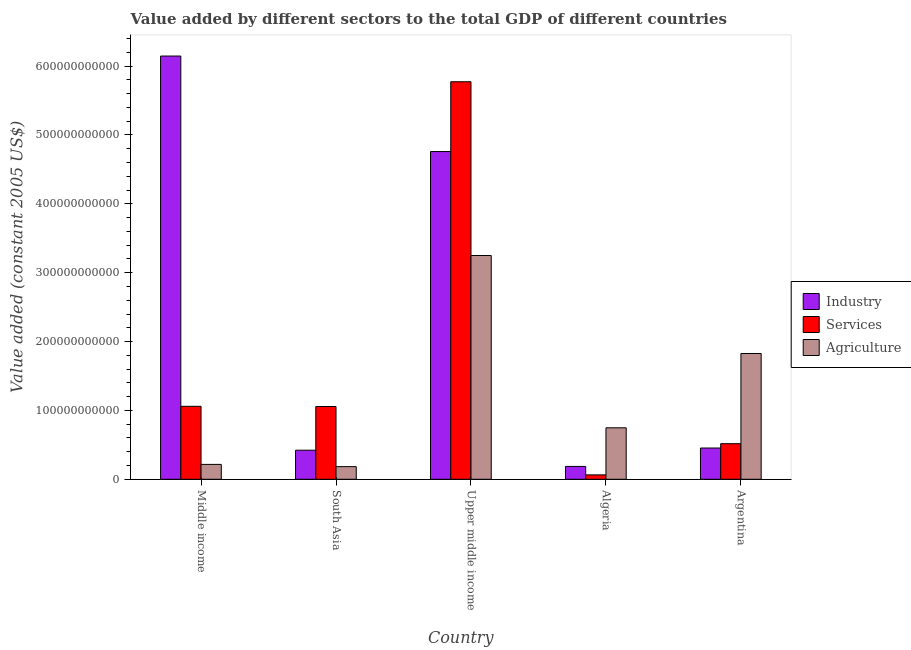How many different coloured bars are there?
Make the answer very short. 3. How many groups of bars are there?
Your answer should be very brief. 5. Are the number of bars on each tick of the X-axis equal?
Provide a short and direct response. Yes. How many bars are there on the 1st tick from the right?
Keep it short and to the point. 3. What is the value added by industrial sector in Argentina?
Your response must be concise. 4.54e+1. Across all countries, what is the maximum value added by services?
Give a very brief answer. 5.77e+11. Across all countries, what is the minimum value added by agricultural sector?
Provide a short and direct response. 1.84e+1. In which country was the value added by agricultural sector maximum?
Make the answer very short. Upper middle income. In which country was the value added by services minimum?
Give a very brief answer. Algeria. What is the total value added by agricultural sector in the graph?
Provide a succinct answer. 6.22e+11. What is the difference between the value added by services in Middle income and that in Upper middle income?
Your answer should be compact. -4.71e+11. What is the difference between the value added by industrial sector in Argentina and the value added by agricultural sector in Upper middle income?
Your answer should be compact. -2.80e+11. What is the average value added by services per country?
Your response must be concise. 1.69e+11. What is the difference between the value added by industrial sector and value added by agricultural sector in Middle income?
Your answer should be very brief. 5.93e+11. In how many countries, is the value added by industrial sector greater than 140000000000 US$?
Make the answer very short. 2. What is the ratio of the value added by agricultural sector in Argentina to that in Upper middle income?
Offer a terse response. 0.56. Is the value added by industrial sector in Algeria less than that in South Asia?
Provide a succinct answer. Yes. Is the difference between the value added by services in Algeria and Argentina greater than the difference between the value added by industrial sector in Algeria and Argentina?
Provide a succinct answer. No. What is the difference between the highest and the second highest value added by services?
Offer a terse response. 4.71e+11. What is the difference between the highest and the lowest value added by agricultural sector?
Offer a terse response. 3.07e+11. Is the sum of the value added by industrial sector in Algeria and South Asia greater than the maximum value added by agricultural sector across all countries?
Your answer should be very brief. No. What does the 2nd bar from the left in Middle income represents?
Your response must be concise. Services. What does the 2nd bar from the right in Upper middle income represents?
Your response must be concise. Services. How many bars are there?
Make the answer very short. 15. How many countries are there in the graph?
Make the answer very short. 5. What is the difference between two consecutive major ticks on the Y-axis?
Provide a succinct answer. 1.00e+11. Are the values on the major ticks of Y-axis written in scientific E-notation?
Provide a succinct answer. No. Where does the legend appear in the graph?
Offer a very short reply. Center right. How many legend labels are there?
Offer a very short reply. 3. What is the title of the graph?
Ensure brevity in your answer.  Value added by different sectors to the total GDP of different countries. What is the label or title of the Y-axis?
Offer a terse response. Value added (constant 2005 US$). What is the Value added (constant 2005 US$) in Industry in Middle income?
Make the answer very short. 6.15e+11. What is the Value added (constant 2005 US$) in Services in Middle income?
Your answer should be compact. 1.06e+11. What is the Value added (constant 2005 US$) in Agriculture in Middle income?
Your answer should be compact. 2.16e+1. What is the Value added (constant 2005 US$) of Industry in South Asia?
Keep it short and to the point. 4.22e+1. What is the Value added (constant 2005 US$) of Services in South Asia?
Offer a terse response. 1.06e+11. What is the Value added (constant 2005 US$) of Agriculture in South Asia?
Provide a short and direct response. 1.84e+1. What is the Value added (constant 2005 US$) in Industry in Upper middle income?
Your response must be concise. 4.76e+11. What is the Value added (constant 2005 US$) of Services in Upper middle income?
Keep it short and to the point. 5.77e+11. What is the Value added (constant 2005 US$) in Agriculture in Upper middle income?
Your answer should be compact. 3.25e+11. What is the Value added (constant 2005 US$) in Industry in Algeria?
Offer a very short reply. 1.86e+1. What is the Value added (constant 2005 US$) in Services in Algeria?
Your answer should be very brief. 6.38e+09. What is the Value added (constant 2005 US$) in Agriculture in Algeria?
Make the answer very short. 7.47e+1. What is the Value added (constant 2005 US$) of Industry in Argentina?
Make the answer very short. 4.54e+1. What is the Value added (constant 2005 US$) of Services in Argentina?
Keep it short and to the point. 5.17e+1. What is the Value added (constant 2005 US$) of Agriculture in Argentina?
Provide a short and direct response. 1.83e+11. Across all countries, what is the maximum Value added (constant 2005 US$) in Industry?
Keep it short and to the point. 6.15e+11. Across all countries, what is the maximum Value added (constant 2005 US$) in Services?
Your answer should be compact. 5.77e+11. Across all countries, what is the maximum Value added (constant 2005 US$) of Agriculture?
Offer a terse response. 3.25e+11. Across all countries, what is the minimum Value added (constant 2005 US$) in Industry?
Your response must be concise. 1.86e+1. Across all countries, what is the minimum Value added (constant 2005 US$) of Services?
Your answer should be very brief. 6.38e+09. Across all countries, what is the minimum Value added (constant 2005 US$) of Agriculture?
Provide a short and direct response. 1.84e+1. What is the total Value added (constant 2005 US$) in Industry in the graph?
Offer a very short reply. 1.20e+12. What is the total Value added (constant 2005 US$) of Services in the graph?
Provide a short and direct response. 8.47e+11. What is the total Value added (constant 2005 US$) of Agriculture in the graph?
Your answer should be very brief. 6.22e+11. What is the difference between the Value added (constant 2005 US$) of Industry in Middle income and that in South Asia?
Ensure brevity in your answer.  5.72e+11. What is the difference between the Value added (constant 2005 US$) in Services in Middle income and that in South Asia?
Ensure brevity in your answer.  3.20e+08. What is the difference between the Value added (constant 2005 US$) in Agriculture in Middle income and that in South Asia?
Keep it short and to the point. 3.24e+09. What is the difference between the Value added (constant 2005 US$) in Industry in Middle income and that in Upper middle income?
Provide a short and direct response. 1.39e+11. What is the difference between the Value added (constant 2005 US$) in Services in Middle income and that in Upper middle income?
Your response must be concise. -4.71e+11. What is the difference between the Value added (constant 2005 US$) of Agriculture in Middle income and that in Upper middle income?
Ensure brevity in your answer.  -3.03e+11. What is the difference between the Value added (constant 2005 US$) of Industry in Middle income and that in Algeria?
Offer a terse response. 5.96e+11. What is the difference between the Value added (constant 2005 US$) in Services in Middle income and that in Algeria?
Give a very brief answer. 9.96e+1. What is the difference between the Value added (constant 2005 US$) of Agriculture in Middle income and that in Algeria?
Give a very brief answer. -5.31e+1. What is the difference between the Value added (constant 2005 US$) in Industry in Middle income and that in Argentina?
Your answer should be compact. 5.69e+11. What is the difference between the Value added (constant 2005 US$) of Services in Middle income and that in Argentina?
Provide a short and direct response. 5.43e+1. What is the difference between the Value added (constant 2005 US$) in Agriculture in Middle income and that in Argentina?
Your answer should be very brief. -1.61e+11. What is the difference between the Value added (constant 2005 US$) in Industry in South Asia and that in Upper middle income?
Ensure brevity in your answer.  -4.34e+11. What is the difference between the Value added (constant 2005 US$) of Services in South Asia and that in Upper middle income?
Your answer should be compact. -4.72e+11. What is the difference between the Value added (constant 2005 US$) in Agriculture in South Asia and that in Upper middle income?
Provide a succinct answer. -3.07e+11. What is the difference between the Value added (constant 2005 US$) of Industry in South Asia and that in Algeria?
Keep it short and to the point. 2.36e+1. What is the difference between the Value added (constant 2005 US$) of Services in South Asia and that in Algeria?
Ensure brevity in your answer.  9.93e+1. What is the difference between the Value added (constant 2005 US$) of Agriculture in South Asia and that in Algeria?
Your answer should be compact. -5.64e+1. What is the difference between the Value added (constant 2005 US$) in Industry in South Asia and that in Argentina?
Make the answer very short. -3.18e+09. What is the difference between the Value added (constant 2005 US$) in Services in South Asia and that in Argentina?
Offer a terse response. 5.40e+1. What is the difference between the Value added (constant 2005 US$) of Agriculture in South Asia and that in Argentina?
Offer a terse response. -1.64e+11. What is the difference between the Value added (constant 2005 US$) of Industry in Upper middle income and that in Algeria?
Offer a very short reply. 4.57e+11. What is the difference between the Value added (constant 2005 US$) in Services in Upper middle income and that in Algeria?
Make the answer very short. 5.71e+11. What is the difference between the Value added (constant 2005 US$) of Agriculture in Upper middle income and that in Algeria?
Offer a terse response. 2.50e+11. What is the difference between the Value added (constant 2005 US$) in Industry in Upper middle income and that in Argentina?
Your response must be concise. 4.31e+11. What is the difference between the Value added (constant 2005 US$) in Services in Upper middle income and that in Argentina?
Your response must be concise. 5.26e+11. What is the difference between the Value added (constant 2005 US$) in Agriculture in Upper middle income and that in Argentina?
Your answer should be very brief. 1.42e+11. What is the difference between the Value added (constant 2005 US$) of Industry in Algeria and that in Argentina?
Give a very brief answer. -2.67e+1. What is the difference between the Value added (constant 2005 US$) of Services in Algeria and that in Argentina?
Your answer should be compact. -4.53e+1. What is the difference between the Value added (constant 2005 US$) in Agriculture in Algeria and that in Argentina?
Provide a short and direct response. -1.08e+11. What is the difference between the Value added (constant 2005 US$) in Industry in Middle income and the Value added (constant 2005 US$) in Services in South Asia?
Provide a succinct answer. 5.09e+11. What is the difference between the Value added (constant 2005 US$) of Industry in Middle income and the Value added (constant 2005 US$) of Agriculture in South Asia?
Provide a succinct answer. 5.96e+11. What is the difference between the Value added (constant 2005 US$) in Services in Middle income and the Value added (constant 2005 US$) in Agriculture in South Asia?
Give a very brief answer. 8.76e+1. What is the difference between the Value added (constant 2005 US$) in Industry in Middle income and the Value added (constant 2005 US$) in Services in Upper middle income?
Your response must be concise. 3.73e+1. What is the difference between the Value added (constant 2005 US$) in Industry in Middle income and the Value added (constant 2005 US$) in Agriculture in Upper middle income?
Provide a succinct answer. 2.90e+11. What is the difference between the Value added (constant 2005 US$) in Services in Middle income and the Value added (constant 2005 US$) in Agriculture in Upper middle income?
Keep it short and to the point. -2.19e+11. What is the difference between the Value added (constant 2005 US$) of Industry in Middle income and the Value added (constant 2005 US$) of Services in Algeria?
Your answer should be very brief. 6.08e+11. What is the difference between the Value added (constant 2005 US$) in Industry in Middle income and the Value added (constant 2005 US$) in Agriculture in Algeria?
Your answer should be compact. 5.40e+11. What is the difference between the Value added (constant 2005 US$) of Services in Middle income and the Value added (constant 2005 US$) of Agriculture in Algeria?
Your answer should be very brief. 3.12e+1. What is the difference between the Value added (constant 2005 US$) in Industry in Middle income and the Value added (constant 2005 US$) in Services in Argentina?
Your response must be concise. 5.63e+11. What is the difference between the Value added (constant 2005 US$) of Industry in Middle income and the Value added (constant 2005 US$) of Agriculture in Argentina?
Give a very brief answer. 4.32e+11. What is the difference between the Value added (constant 2005 US$) of Services in Middle income and the Value added (constant 2005 US$) of Agriculture in Argentina?
Ensure brevity in your answer.  -7.67e+1. What is the difference between the Value added (constant 2005 US$) of Industry in South Asia and the Value added (constant 2005 US$) of Services in Upper middle income?
Your answer should be very brief. -5.35e+11. What is the difference between the Value added (constant 2005 US$) of Industry in South Asia and the Value added (constant 2005 US$) of Agriculture in Upper middle income?
Provide a short and direct response. -2.83e+11. What is the difference between the Value added (constant 2005 US$) in Services in South Asia and the Value added (constant 2005 US$) in Agriculture in Upper middle income?
Make the answer very short. -2.19e+11. What is the difference between the Value added (constant 2005 US$) of Industry in South Asia and the Value added (constant 2005 US$) of Services in Algeria?
Offer a very short reply. 3.58e+1. What is the difference between the Value added (constant 2005 US$) in Industry in South Asia and the Value added (constant 2005 US$) in Agriculture in Algeria?
Ensure brevity in your answer.  -3.25e+1. What is the difference between the Value added (constant 2005 US$) of Services in South Asia and the Value added (constant 2005 US$) of Agriculture in Algeria?
Your answer should be very brief. 3.09e+1. What is the difference between the Value added (constant 2005 US$) in Industry in South Asia and the Value added (constant 2005 US$) in Services in Argentina?
Make the answer very short. -9.47e+09. What is the difference between the Value added (constant 2005 US$) in Industry in South Asia and the Value added (constant 2005 US$) in Agriculture in Argentina?
Give a very brief answer. -1.40e+11. What is the difference between the Value added (constant 2005 US$) of Services in South Asia and the Value added (constant 2005 US$) of Agriculture in Argentina?
Ensure brevity in your answer.  -7.70e+1. What is the difference between the Value added (constant 2005 US$) of Industry in Upper middle income and the Value added (constant 2005 US$) of Services in Algeria?
Offer a terse response. 4.70e+11. What is the difference between the Value added (constant 2005 US$) of Industry in Upper middle income and the Value added (constant 2005 US$) of Agriculture in Algeria?
Provide a short and direct response. 4.01e+11. What is the difference between the Value added (constant 2005 US$) of Services in Upper middle income and the Value added (constant 2005 US$) of Agriculture in Algeria?
Your response must be concise. 5.03e+11. What is the difference between the Value added (constant 2005 US$) of Industry in Upper middle income and the Value added (constant 2005 US$) of Services in Argentina?
Your response must be concise. 4.24e+11. What is the difference between the Value added (constant 2005 US$) of Industry in Upper middle income and the Value added (constant 2005 US$) of Agriculture in Argentina?
Keep it short and to the point. 2.93e+11. What is the difference between the Value added (constant 2005 US$) in Services in Upper middle income and the Value added (constant 2005 US$) in Agriculture in Argentina?
Your answer should be very brief. 3.95e+11. What is the difference between the Value added (constant 2005 US$) of Industry in Algeria and the Value added (constant 2005 US$) of Services in Argentina?
Your answer should be very brief. -3.30e+1. What is the difference between the Value added (constant 2005 US$) of Industry in Algeria and the Value added (constant 2005 US$) of Agriculture in Argentina?
Provide a succinct answer. -1.64e+11. What is the difference between the Value added (constant 2005 US$) of Services in Algeria and the Value added (constant 2005 US$) of Agriculture in Argentina?
Your answer should be compact. -1.76e+11. What is the average Value added (constant 2005 US$) in Industry per country?
Make the answer very short. 2.39e+11. What is the average Value added (constant 2005 US$) in Services per country?
Your answer should be very brief. 1.69e+11. What is the average Value added (constant 2005 US$) in Agriculture per country?
Your answer should be compact. 1.24e+11. What is the difference between the Value added (constant 2005 US$) in Industry and Value added (constant 2005 US$) in Services in Middle income?
Your response must be concise. 5.09e+11. What is the difference between the Value added (constant 2005 US$) in Industry and Value added (constant 2005 US$) in Agriculture in Middle income?
Offer a very short reply. 5.93e+11. What is the difference between the Value added (constant 2005 US$) in Services and Value added (constant 2005 US$) in Agriculture in Middle income?
Offer a terse response. 8.44e+1. What is the difference between the Value added (constant 2005 US$) in Industry and Value added (constant 2005 US$) in Services in South Asia?
Ensure brevity in your answer.  -6.34e+1. What is the difference between the Value added (constant 2005 US$) of Industry and Value added (constant 2005 US$) of Agriculture in South Asia?
Your answer should be very brief. 2.39e+1. What is the difference between the Value added (constant 2005 US$) in Services and Value added (constant 2005 US$) in Agriculture in South Asia?
Provide a succinct answer. 8.73e+1. What is the difference between the Value added (constant 2005 US$) in Industry and Value added (constant 2005 US$) in Services in Upper middle income?
Offer a terse response. -1.01e+11. What is the difference between the Value added (constant 2005 US$) of Industry and Value added (constant 2005 US$) of Agriculture in Upper middle income?
Your response must be concise. 1.51e+11. What is the difference between the Value added (constant 2005 US$) in Services and Value added (constant 2005 US$) in Agriculture in Upper middle income?
Ensure brevity in your answer.  2.52e+11. What is the difference between the Value added (constant 2005 US$) in Industry and Value added (constant 2005 US$) in Services in Algeria?
Make the answer very short. 1.23e+1. What is the difference between the Value added (constant 2005 US$) in Industry and Value added (constant 2005 US$) in Agriculture in Algeria?
Keep it short and to the point. -5.61e+1. What is the difference between the Value added (constant 2005 US$) in Services and Value added (constant 2005 US$) in Agriculture in Algeria?
Offer a very short reply. -6.84e+1. What is the difference between the Value added (constant 2005 US$) in Industry and Value added (constant 2005 US$) in Services in Argentina?
Give a very brief answer. -6.29e+09. What is the difference between the Value added (constant 2005 US$) in Industry and Value added (constant 2005 US$) in Agriculture in Argentina?
Your response must be concise. -1.37e+11. What is the difference between the Value added (constant 2005 US$) in Services and Value added (constant 2005 US$) in Agriculture in Argentina?
Offer a very short reply. -1.31e+11. What is the ratio of the Value added (constant 2005 US$) in Industry in Middle income to that in South Asia?
Provide a short and direct response. 14.56. What is the ratio of the Value added (constant 2005 US$) of Services in Middle income to that in South Asia?
Ensure brevity in your answer.  1. What is the ratio of the Value added (constant 2005 US$) of Agriculture in Middle income to that in South Asia?
Make the answer very short. 1.18. What is the ratio of the Value added (constant 2005 US$) of Industry in Middle income to that in Upper middle income?
Provide a short and direct response. 1.29. What is the ratio of the Value added (constant 2005 US$) in Services in Middle income to that in Upper middle income?
Offer a very short reply. 0.18. What is the ratio of the Value added (constant 2005 US$) of Agriculture in Middle income to that in Upper middle income?
Give a very brief answer. 0.07. What is the ratio of the Value added (constant 2005 US$) in Industry in Middle income to that in Algeria?
Offer a terse response. 32.96. What is the ratio of the Value added (constant 2005 US$) in Services in Middle income to that in Algeria?
Your response must be concise. 16.61. What is the ratio of the Value added (constant 2005 US$) in Agriculture in Middle income to that in Algeria?
Your response must be concise. 0.29. What is the ratio of the Value added (constant 2005 US$) of Industry in Middle income to that in Argentina?
Your answer should be compact. 13.54. What is the ratio of the Value added (constant 2005 US$) in Services in Middle income to that in Argentina?
Your response must be concise. 2.05. What is the ratio of the Value added (constant 2005 US$) in Agriculture in Middle income to that in Argentina?
Provide a short and direct response. 0.12. What is the ratio of the Value added (constant 2005 US$) in Industry in South Asia to that in Upper middle income?
Your answer should be compact. 0.09. What is the ratio of the Value added (constant 2005 US$) in Services in South Asia to that in Upper middle income?
Make the answer very short. 0.18. What is the ratio of the Value added (constant 2005 US$) of Agriculture in South Asia to that in Upper middle income?
Provide a succinct answer. 0.06. What is the ratio of the Value added (constant 2005 US$) in Industry in South Asia to that in Algeria?
Make the answer very short. 2.26. What is the ratio of the Value added (constant 2005 US$) in Services in South Asia to that in Algeria?
Your answer should be very brief. 16.56. What is the ratio of the Value added (constant 2005 US$) in Agriculture in South Asia to that in Algeria?
Your answer should be very brief. 0.25. What is the ratio of the Value added (constant 2005 US$) in Industry in South Asia to that in Argentina?
Keep it short and to the point. 0.93. What is the ratio of the Value added (constant 2005 US$) in Services in South Asia to that in Argentina?
Give a very brief answer. 2.04. What is the ratio of the Value added (constant 2005 US$) in Agriculture in South Asia to that in Argentina?
Make the answer very short. 0.1. What is the ratio of the Value added (constant 2005 US$) in Industry in Upper middle income to that in Algeria?
Offer a terse response. 25.52. What is the ratio of the Value added (constant 2005 US$) in Services in Upper middle income to that in Algeria?
Ensure brevity in your answer.  90.49. What is the ratio of the Value added (constant 2005 US$) in Agriculture in Upper middle income to that in Algeria?
Your answer should be compact. 4.35. What is the ratio of the Value added (constant 2005 US$) in Industry in Upper middle income to that in Argentina?
Ensure brevity in your answer.  10.48. What is the ratio of the Value added (constant 2005 US$) of Services in Upper middle income to that in Argentina?
Give a very brief answer. 11.17. What is the ratio of the Value added (constant 2005 US$) of Agriculture in Upper middle income to that in Argentina?
Keep it short and to the point. 1.78. What is the ratio of the Value added (constant 2005 US$) of Industry in Algeria to that in Argentina?
Keep it short and to the point. 0.41. What is the ratio of the Value added (constant 2005 US$) of Services in Algeria to that in Argentina?
Offer a terse response. 0.12. What is the ratio of the Value added (constant 2005 US$) of Agriculture in Algeria to that in Argentina?
Ensure brevity in your answer.  0.41. What is the difference between the highest and the second highest Value added (constant 2005 US$) in Industry?
Offer a very short reply. 1.39e+11. What is the difference between the highest and the second highest Value added (constant 2005 US$) of Services?
Your answer should be very brief. 4.71e+11. What is the difference between the highest and the second highest Value added (constant 2005 US$) of Agriculture?
Provide a short and direct response. 1.42e+11. What is the difference between the highest and the lowest Value added (constant 2005 US$) in Industry?
Ensure brevity in your answer.  5.96e+11. What is the difference between the highest and the lowest Value added (constant 2005 US$) in Services?
Your response must be concise. 5.71e+11. What is the difference between the highest and the lowest Value added (constant 2005 US$) of Agriculture?
Provide a succinct answer. 3.07e+11. 